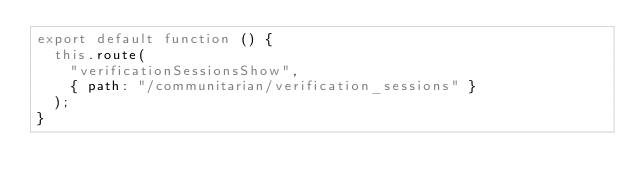<code> <loc_0><loc_0><loc_500><loc_500><_JavaScript_>export default function () {
  this.route(
    "verificationSessionsShow",
    { path: "/communitarian/verification_sessions" }
  );
}
</code> 